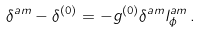Convert formula to latex. <formula><loc_0><loc_0><loc_500><loc_500>\delta ^ { \L a m } - \delta ^ { ( 0 ) } = - g ^ { ( 0 ) } \delta ^ { \L a m } l ^ { \L a m } _ { \phi } \, .</formula> 